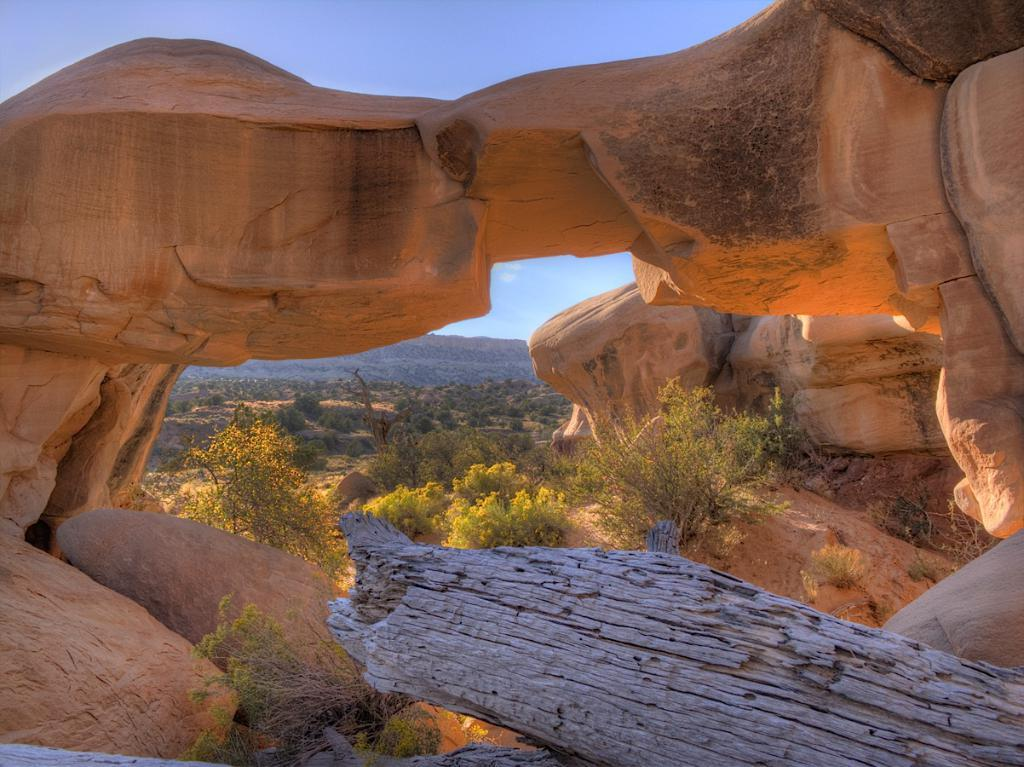What color are the mountains in the image? The mountains in the image are brown in color. What can be seen at the bottom front of the image? There is a dry tree trunk in the front bottom side of the image. What type of vegetation is visible in the background of the image? There are trees visible in the background of the image. What other geographical feature is visible in the background of the image? There are mountains in the background of the image. How does the wind affect the arm of the person in the image? There is no person or arm present in the image; it features mountains and trees. 